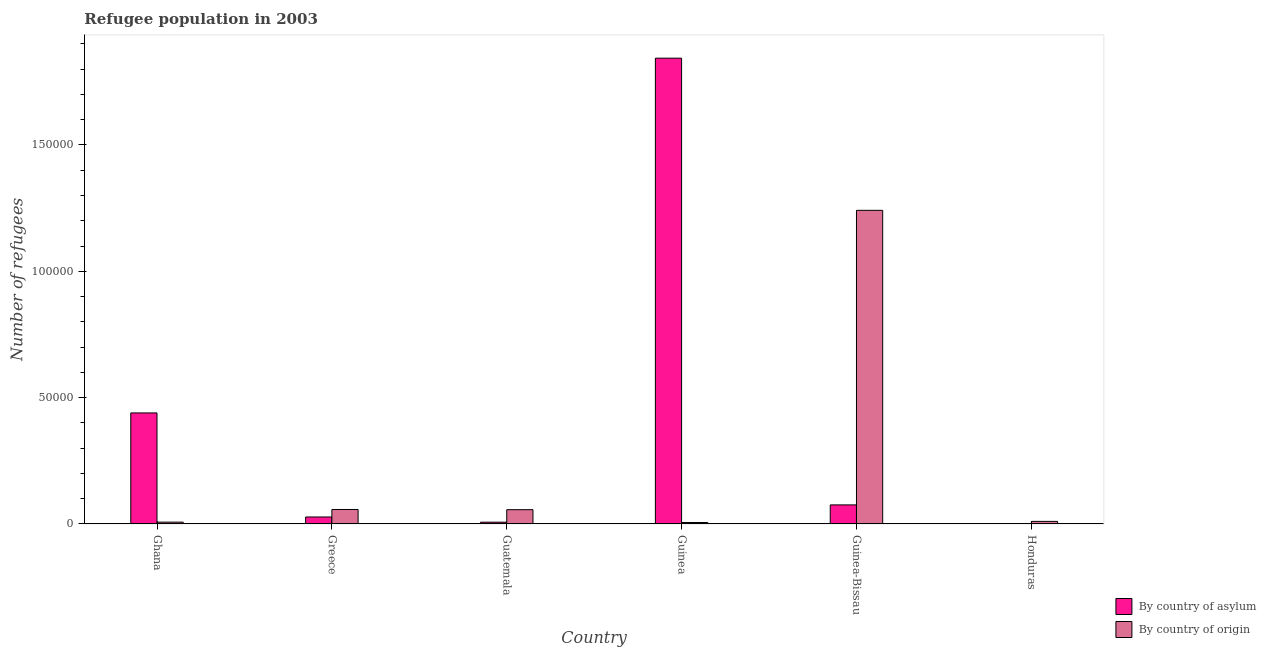Are the number of bars per tick equal to the number of legend labels?
Your response must be concise. Yes. Are the number of bars on each tick of the X-axis equal?
Keep it short and to the point. Yes. How many bars are there on the 2nd tick from the left?
Keep it short and to the point. 2. In how many cases, is the number of bars for a given country not equal to the number of legend labels?
Keep it short and to the point. 0. What is the number of refugees by country of origin in Guinea?
Provide a short and direct response. 591. Across all countries, what is the maximum number of refugees by country of asylum?
Provide a succinct answer. 1.84e+05. Across all countries, what is the minimum number of refugees by country of asylum?
Your response must be concise. 23. In which country was the number of refugees by country of asylum maximum?
Offer a terse response. Guinea. In which country was the number of refugees by country of asylum minimum?
Offer a terse response. Honduras. What is the total number of refugees by country of asylum in the graph?
Provide a short and direct response. 2.39e+05. What is the difference between the number of refugees by country of asylum in Guatemala and that in Guinea?
Make the answer very short. -1.84e+05. What is the difference between the number of refugees by country of asylum in Greece and the number of refugees by country of origin in Guatemala?
Ensure brevity in your answer.  -2887. What is the average number of refugees by country of origin per country?
Provide a succinct answer. 2.30e+04. What is the difference between the number of refugees by country of asylum and number of refugees by country of origin in Guatemala?
Provide a succinct answer. -4943. In how many countries, is the number of refugees by country of asylum greater than 30000 ?
Provide a short and direct response. 2. What is the ratio of the number of refugees by country of origin in Guinea-Bissau to that in Honduras?
Your response must be concise. 120.86. Is the number of refugees by country of asylum in Guinea less than that in Honduras?
Your answer should be very brief. No. Is the difference between the number of refugees by country of asylum in Guatemala and Guinea greater than the difference between the number of refugees by country of origin in Guatemala and Guinea?
Provide a short and direct response. No. What is the difference between the highest and the second highest number of refugees by country of origin?
Provide a succinct answer. 1.18e+05. What is the difference between the highest and the lowest number of refugees by country of origin?
Offer a very short reply. 1.24e+05. In how many countries, is the number of refugees by country of origin greater than the average number of refugees by country of origin taken over all countries?
Give a very brief answer. 1. Is the sum of the number of refugees by country of asylum in Guinea and Guinea-Bissau greater than the maximum number of refugees by country of origin across all countries?
Make the answer very short. Yes. What does the 1st bar from the left in Guinea-Bissau represents?
Your answer should be very brief. By country of asylum. What does the 2nd bar from the right in Guinea-Bissau represents?
Your response must be concise. By country of asylum. How many bars are there?
Give a very brief answer. 12. Does the graph contain any zero values?
Make the answer very short. No. Does the graph contain grids?
Provide a short and direct response. No. How are the legend labels stacked?
Offer a very short reply. Vertical. What is the title of the graph?
Offer a terse response. Refugee population in 2003. What is the label or title of the X-axis?
Give a very brief answer. Country. What is the label or title of the Y-axis?
Your response must be concise. Number of refugees. What is the Number of refugees of By country of asylum in Ghana?
Your answer should be very brief. 4.39e+04. What is the Number of refugees in By country of origin in Ghana?
Offer a terse response. 730. What is the Number of refugees in By country of asylum in Greece?
Offer a very short reply. 2771. What is the Number of refugees of By country of origin in Greece?
Provide a succinct answer. 5735. What is the Number of refugees of By country of asylum in Guatemala?
Your answer should be very brief. 715. What is the Number of refugees in By country of origin in Guatemala?
Provide a short and direct response. 5658. What is the Number of refugees of By country of asylum in Guinea?
Make the answer very short. 1.84e+05. What is the Number of refugees in By country of origin in Guinea?
Make the answer very short. 591. What is the Number of refugees of By country of asylum in Guinea-Bissau?
Keep it short and to the point. 7551. What is the Number of refugees in By country of origin in Guinea-Bissau?
Provide a short and direct response. 1.24e+05. What is the Number of refugees of By country of asylum in Honduras?
Ensure brevity in your answer.  23. What is the Number of refugees in By country of origin in Honduras?
Offer a terse response. 1027. Across all countries, what is the maximum Number of refugees of By country of asylum?
Your answer should be compact. 1.84e+05. Across all countries, what is the maximum Number of refugees in By country of origin?
Offer a terse response. 1.24e+05. Across all countries, what is the minimum Number of refugees in By country of origin?
Provide a succinct answer. 591. What is the total Number of refugees in By country of asylum in the graph?
Give a very brief answer. 2.39e+05. What is the total Number of refugees in By country of origin in the graph?
Keep it short and to the point. 1.38e+05. What is the difference between the Number of refugees of By country of asylum in Ghana and that in Greece?
Give a very brief answer. 4.12e+04. What is the difference between the Number of refugees in By country of origin in Ghana and that in Greece?
Make the answer very short. -5005. What is the difference between the Number of refugees of By country of asylum in Ghana and that in Guatemala?
Your answer should be compact. 4.32e+04. What is the difference between the Number of refugees of By country of origin in Ghana and that in Guatemala?
Provide a succinct answer. -4928. What is the difference between the Number of refugees in By country of asylum in Ghana and that in Guinea?
Offer a terse response. -1.40e+05. What is the difference between the Number of refugees of By country of origin in Ghana and that in Guinea?
Your answer should be very brief. 139. What is the difference between the Number of refugees of By country of asylum in Ghana and that in Guinea-Bissau?
Give a very brief answer. 3.64e+04. What is the difference between the Number of refugees of By country of origin in Ghana and that in Guinea-Bissau?
Offer a very short reply. -1.23e+05. What is the difference between the Number of refugees in By country of asylum in Ghana and that in Honduras?
Make the answer very short. 4.39e+04. What is the difference between the Number of refugees in By country of origin in Ghana and that in Honduras?
Your response must be concise. -297. What is the difference between the Number of refugees of By country of asylum in Greece and that in Guatemala?
Your answer should be very brief. 2056. What is the difference between the Number of refugees of By country of origin in Greece and that in Guatemala?
Your response must be concise. 77. What is the difference between the Number of refugees of By country of asylum in Greece and that in Guinea?
Your answer should be very brief. -1.82e+05. What is the difference between the Number of refugees in By country of origin in Greece and that in Guinea?
Provide a succinct answer. 5144. What is the difference between the Number of refugees in By country of asylum in Greece and that in Guinea-Bissau?
Provide a short and direct response. -4780. What is the difference between the Number of refugees of By country of origin in Greece and that in Guinea-Bissau?
Provide a succinct answer. -1.18e+05. What is the difference between the Number of refugees in By country of asylum in Greece and that in Honduras?
Your response must be concise. 2748. What is the difference between the Number of refugees of By country of origin in Greece and that in Honduras?
Keep it short and to the point. 4708. What is the difference between the Number of refugees in By country of asylum in Guatemala and that in Guinea?
Your answer should be compact. -1.84e+05. What is the difference between the Number of refugees in By country of origin in Guatemala and that in Guinea?
Make the answer very short. 5067. What is the difference between the Number of refugees in By country of asylum in Guatemala and that in Guinea-Bissau?
Give a very brief answer. -6836. What is the difference between the Number of refugees of By country of origin in Guatemala and that in Guinea-Bissau?
Your response must be concise. -1.18e+05. What is the difference between the Number of refugees of By country of asylum in Guatemala and that in Honduras?
Offer a very short reply. 692. What is the difference between the Number of refugees in By country of origin in Guatemala and that in Honduras?
Offer a very short reply. 4631. What is the difference between the Number of refugees in By country of asylum in Guinea and that in Guinea-Bissau?
Your response must be concise. 1.77e+05. What is the difference between the Number of refugees in By country of origin in Guinea and that in Guinea-Bissau?
Keep it short and to the point. -1.24e+05. What is the difference between the Number of refugees in By country of asylum in Guinea and that in Honduras?
Ensure brevity in your answer.  1.84e+05. What is the difference between the Number of refugees in By country of origin in Guinea and that in Honduras?
Your answer should be very brief. -436. What is the difference between the Number of refugees in By country of asylum in Guinea-Bissau and that in Honduras?
Give a very brief answer. 7528. What is the difference between the Number of refugees of By country of origin in Guinea-Bissau and that in Honduras?
Your answer should be compact. 1.23e+05. What is the difference between the Number of refugees of By country of asylum in Ghana and the Number of refugees of By country of origin in Greece?
Provide a short and direct response. 3.82e+04. What is the difference between the Number of refugees of By country of asylum in Ghana and the Number of refugees of By country of origin in Guatemala?
Offer a very short reply. 3.83e+04. What is the difference between the Number of refugees in By country of asylum in Ghana and the Number of refugees in By country of origin in Guinea?
Offer a terse response. 4.34e+04. What is the difference between the Number of refugees in By country of asylum in Ghana and the Number of refugees in By country of origin in Guinea-Bissau?
Give a very brief answer. -8.02e+04. What is the difference between the Number of refugees of By country of asylum in Ghana and the Number of refugees of By country of origin in Honduras?
Your answer should be very brief. 4.29e+04. What is the difference between the Number of refugees in By country of asylum in Greece and the Number of refugees in By country of origin in Guatemala?
Give a very brief answer. -2887. What is the difference between the Number of refugees of By country of asylum in Greece and the Number of refugees of By country of origin in Guinea?
Offer a very short reply. 2180. What is the difference between the Number of refugees of By country of asylum in Greece and the Number of refugees of By country of origin in Guinea-Bissau?
Keep it short and to the point. -1.21e+05. What is the difference between the Number of refugees in By country of asylum in Greece and the Number of refugees in By country of origin in Honduras?
Ensure brevity in your answer.  1744. What is the difference between the Number of refugees in By country of asylum in Guatemala and the Number of refugees in By country of origin in Guinea?
Ensure brevity in your answer.  124. What is the difference between the Number of refugees in By country of asylum in Guatemala and the Number of refugees in By country of origin in Guinea-Bissau?
Make the answer very short. -1.23e+05. What is the difference between the Number of refugees in By country of asylum in Guatemala and the Number of refugees in By country of origin in Honduras?
Keep it short and to the point. -312. What is the difference between the Number of refugees of By country of asylum in Guinea and the Number of refugees of By country of origin in Guinea-Bissau?
Provide a short and direct response. 6.02e+04. What is the difference between the Number of refugees in By country of asylum in Guinea and the Number of refugees in By country of origin in Honduras?
Your answer should be very brief. 1.83e+05. What is the difference between the Number of refugees in By country of asylum in Guinea-Bissau and the Number of refugees in By country of origin in Honduras?
Give a very brief answer. 6524. What is the average Number of refugees in By country of asylum per country?
Make the answer very short. 3.99e+04. What is the average Number of refugees of By country of origin per country?
Your response must be concise. 2.30e+04. What is the difference between the Number of refugees in By country of asylum and Number of refugees in By country of origin in Ghana?
Ensure brevity in your answer.  4.32e+04. What is the difference between the Number of refugees in By country of asylum and Number of refugees in By country of origin in Greece?
Offer a very short reply. -2964. What is the difference between the Number of refugees in By country of asylum and Number of refugees in By country of origin in Guatemala?
Your response must be concise. -4943. What is the difference between the Number of refugees in By country of asylum and Number of refugees in By country of origin in Guinea?
Ensure brevity in your answer.  1.84e+05. What is the difference between the Number of refugees in By country of asylum and Number of refugees in By country of origin in Guinea-Bissau?
Provide a succinct answer. -1.17e+05. What is the difference between the Number of refugees in By country of asylum and Number of refugees in By country of origin in Honduras?
Keep it short and to the point. -1004. What is the ratio of the Number of refugees in By country of asylum in Ghana to that in Greece?
Give a very brief answer. 15.86. What is the ratio of the Number of refugees in By country of origin in Ghana to that in Greece?
Ensure brevity in your answer.  0.13. What is the ratio of the Number of refugees of By country of asylum in Ghana to that in Guatemala?
Your answer should be compact. 61.46. What is the ratio of the Number of refugees of By country of origin in Ghana to that in Guatemala?
Provide a short and direct response. 0.13. What is the ratio of the Number of refugees of By country of asylum in Ghana to that in Guinea?
Ensure brevity in your answer.  0.24. What is the ratio of the Number of refugees in By country of origin in Ghana to that in Guinea?
Provide a short and direct response. 1.24. What is the ratio of the Number of refugees of By country of asylum in Ghana to that in Guinea-Bissau?
Your response must be concise. 5.82. What is the ratio of the Number of refugees in By country of origin in Ghana to that in Guinea-Bissau?
Your answer should be very brief. 0.01. What is the ratio of the Number of refugees in By country of asylum in Ghana to that in Honduras?
Your response must be concise. 1910.74. What is the ratio of the Number of refugees of By country of origin in Ghana to that in Honduras?
Provide a succinct answer. 0.71. What is the ratio of the Number of refugees in By country of asylum in Greece to that in Guatemala?
Your answer should be compact. 3.88. What is the ratio of the Number of refugees of By country of origin in Greece to that in Guatemala?
Make the answer very short. 1.01. What is the ratio of the Number of refugees of By country of asylum in Greece to that in Guinea?
Ensure brevity in your answer.  0.01. What is the ratio of the Number of refugees in By country of origin in Greece to that in Guinea?
Your response must be concise. 9.7. What is the ratio of the Number of refugees of By country of asylum in Greece to that in Guinea-Bissau?
Make the answer very short. 0.37. What is the ratio of the Number of refugees of By country of origin in Greece to that in Guinea-Bissau?
Provide a succinct answer. 0.05. What is the ratio of the Number of refugees in By country of asylum in Greece to that in Honduras?
Provide a succinct answer. 120.48. What is the ratio of the Number of refugees of By country of origin in Greece to that in Honduras?
Give a very brief answer. 5.58. What is the ratio of the Number of refugees in By country of asylum in Guatemala to that in Guinea?
Offer a very short reply. 0. What is the ratio of the Number of refugees in By country of origin in Guatemala to that in Guinea?
Give a very brief answer. 9.57. What is the ratio of the Number of refugees in By country of asylum in Guatemala to that in Guinea-Bissau?
Your response must be concise. 0.09. What is the ratio of the Number of refugees of By country of origin in Guatemala to that in Guinea-Bissau?
Keep it short and to the point. 0.05. What is the ratio of the Number of refugees of By country of asylum in Guatemala to that in Honduras?
Ensure brevity in your answer.  31.09. What is the ratio of the Number of refugees of By country of origin in Guatemala to that in Honduras?
Provide a succinct answer. 5.51. What is the ratio of the Number of refugees in By country of asylum in Guinea to that in Guinea-Bissau?
Offer a terse response. 24.41. What is the ratio of the Number of refugees of By country of origin in Guinea to that in Guinea-Bissau?
Make the answer very short. 0. What is the ratio of the Number of refugees in By country of asylum in Guinea to that in Honduras?
Give a very brief answer. 8014.83. What is the ratio of the Number of refugees of By country of origin in Guinea to that in Honduras?
Your answer should be very brief. 0.58. What is the ratio of the Number of refugees of By country of asylum in Guinea-Bissau to that in Honduras?
Ensure brevity in your answer.  328.3. What is the ratio of the Number of refugees in By country of origin in Guinea-Bissau to that in Honduras?
Keep it short and to the point. 120.86. What is the difference between the highest and the second highest Number of refugees in By country of asylum?
Provide a succinct answer. 1.40e+05. What is the difference between the highest and the second highest Number of refugees in By country of origin?
Provide a short and direct response. 1.18e+05. What is the difference between the highest and the lowest Number of refugees of By country of asylum?
Offer a very short reply. 1.84e+05. What is the difference between the highest and the lowest Number of refugees in By country of origin?
Provide a succinct answer. 1.24e+05. 